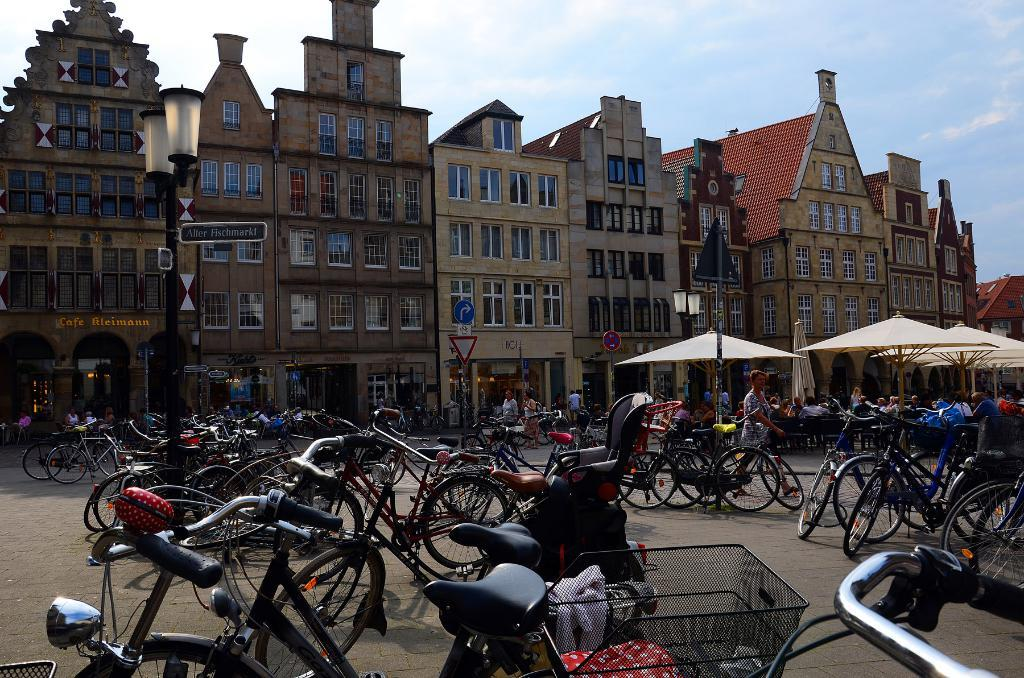What is the condition of the sky in the image? The sky is cloudy in the image. What type of structures can be seen in the image? There are buildings in the image. What part of the buildings can be seen in the image? Windows are visible in the image. What type of street furniture is present in the image? Light poles are present in the image. What type of signage is visible in the image? Signboards are visible in the image. What type of protective gear is present in the image? Umbrellas are in the image. Who is present in the image? People are present in the image. What type of transportation is visible in the image? Bicycles are visible in the image. What type of snail can be seen crawling on the signboard in the image? There is no snail present on the signboard in the image. What type of veil is being worn by the people in the image? There is no veil being worn by the people in the image. 